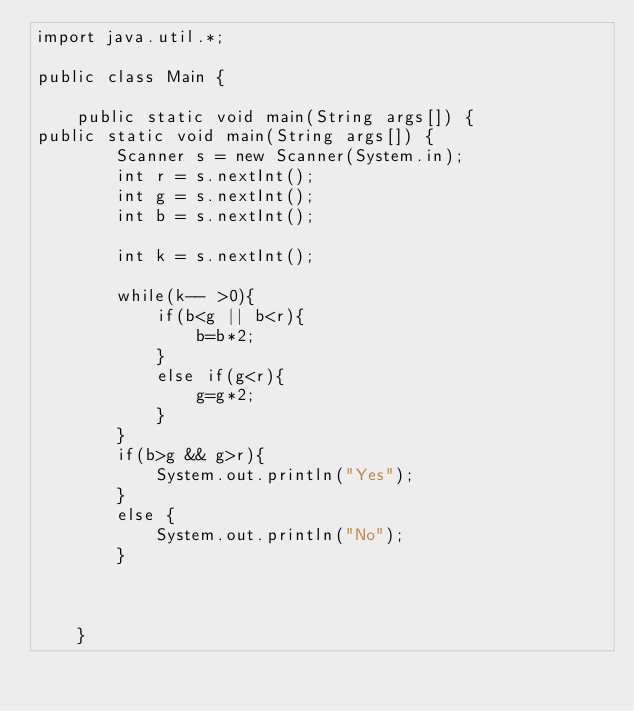<code> <loc_0><loc_0><loc_500><loc_500><_Java_>import java.util.*;

public class Main {

    public static void main(String args[]) {
public static void main(String args[]) {
        Scanner s = new Scanner(System.in);
        int r = s.nextInt();
        int g = s.nextInt();
        int b = s.nextInt();

        int k = s.nextInt();

        while(k-- >0){
            if(b<g || b<r){
                b=b*2;
            }
            else if(g<r){
                g=g*2;
            }
        }
        if(b>g && g>r){
            System.out.println("Yes");
        }
        else {
            System.out.println("No");
        }



    }

</code> 